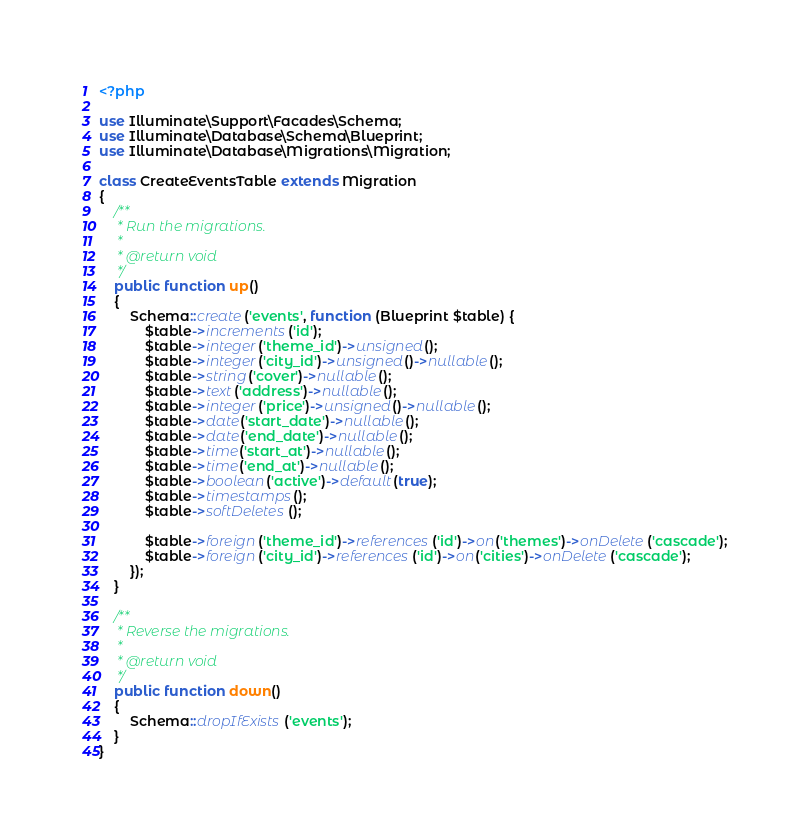<code> <loc_0><loc_0><loc_500><loc_500><_PHP_><?php

use Illuminate\Support\Facades\Schema;
use Illuminate\Database\Schema\Blueprint;
use Illuminate\Database\Migrations\Migration;

class CreateEventsTable extends Migration
{
    /**
     * Run the migrations.
     *
     * @return void
     */
    public function up()
    {
        Schema::create('events', function (Blueprint $table) {
            $table->increments('id');
            $table->integer('theme_id')->unsigned();
            $table->integer('city_id')->unsigned()->nullable();
            $table->string('cover')->nullable();
            $table->text('address')->nullable();
            $table->integer('price')->unsigned()->nullable();
            $table->date('start_date')->nullable();
            $table->date('end_date')->nullable();
            $table->time('start_at')->nullable();
            $table->time('end_at')->nullable();
            $table->boolean('active')->default(true);
            $table->timestamps();
            $table->softDeletes();

            $table->foreign('theme_id')->references('id')->on('themes')->onDelete('cascade');
            $table->foreign('city_id')->references('id')->on('cities')->onDelete('cascade');
        });
    }

    /**
     * Reverse the migrations.
     *
     * @return void
     */
    public function down()
    {
        Schema::dropIfExists('events');
    }
}
</code> 